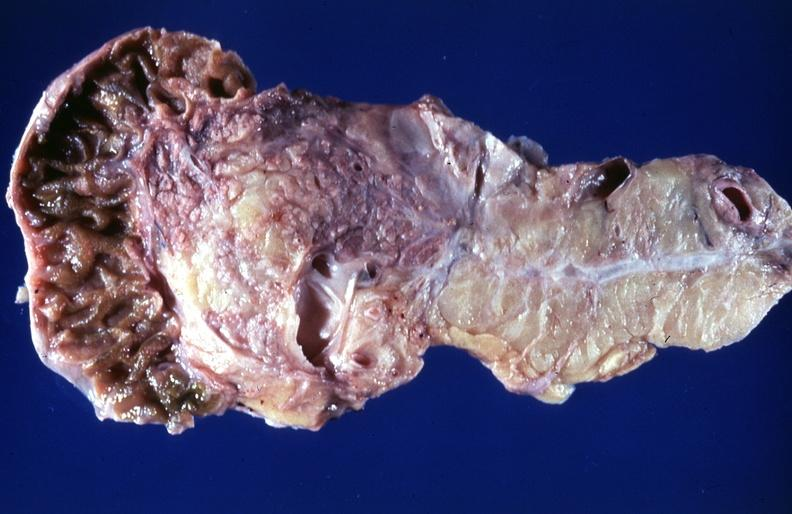what does this image show?
Answer the question using a single word or phrase. Cystic fibrosis 